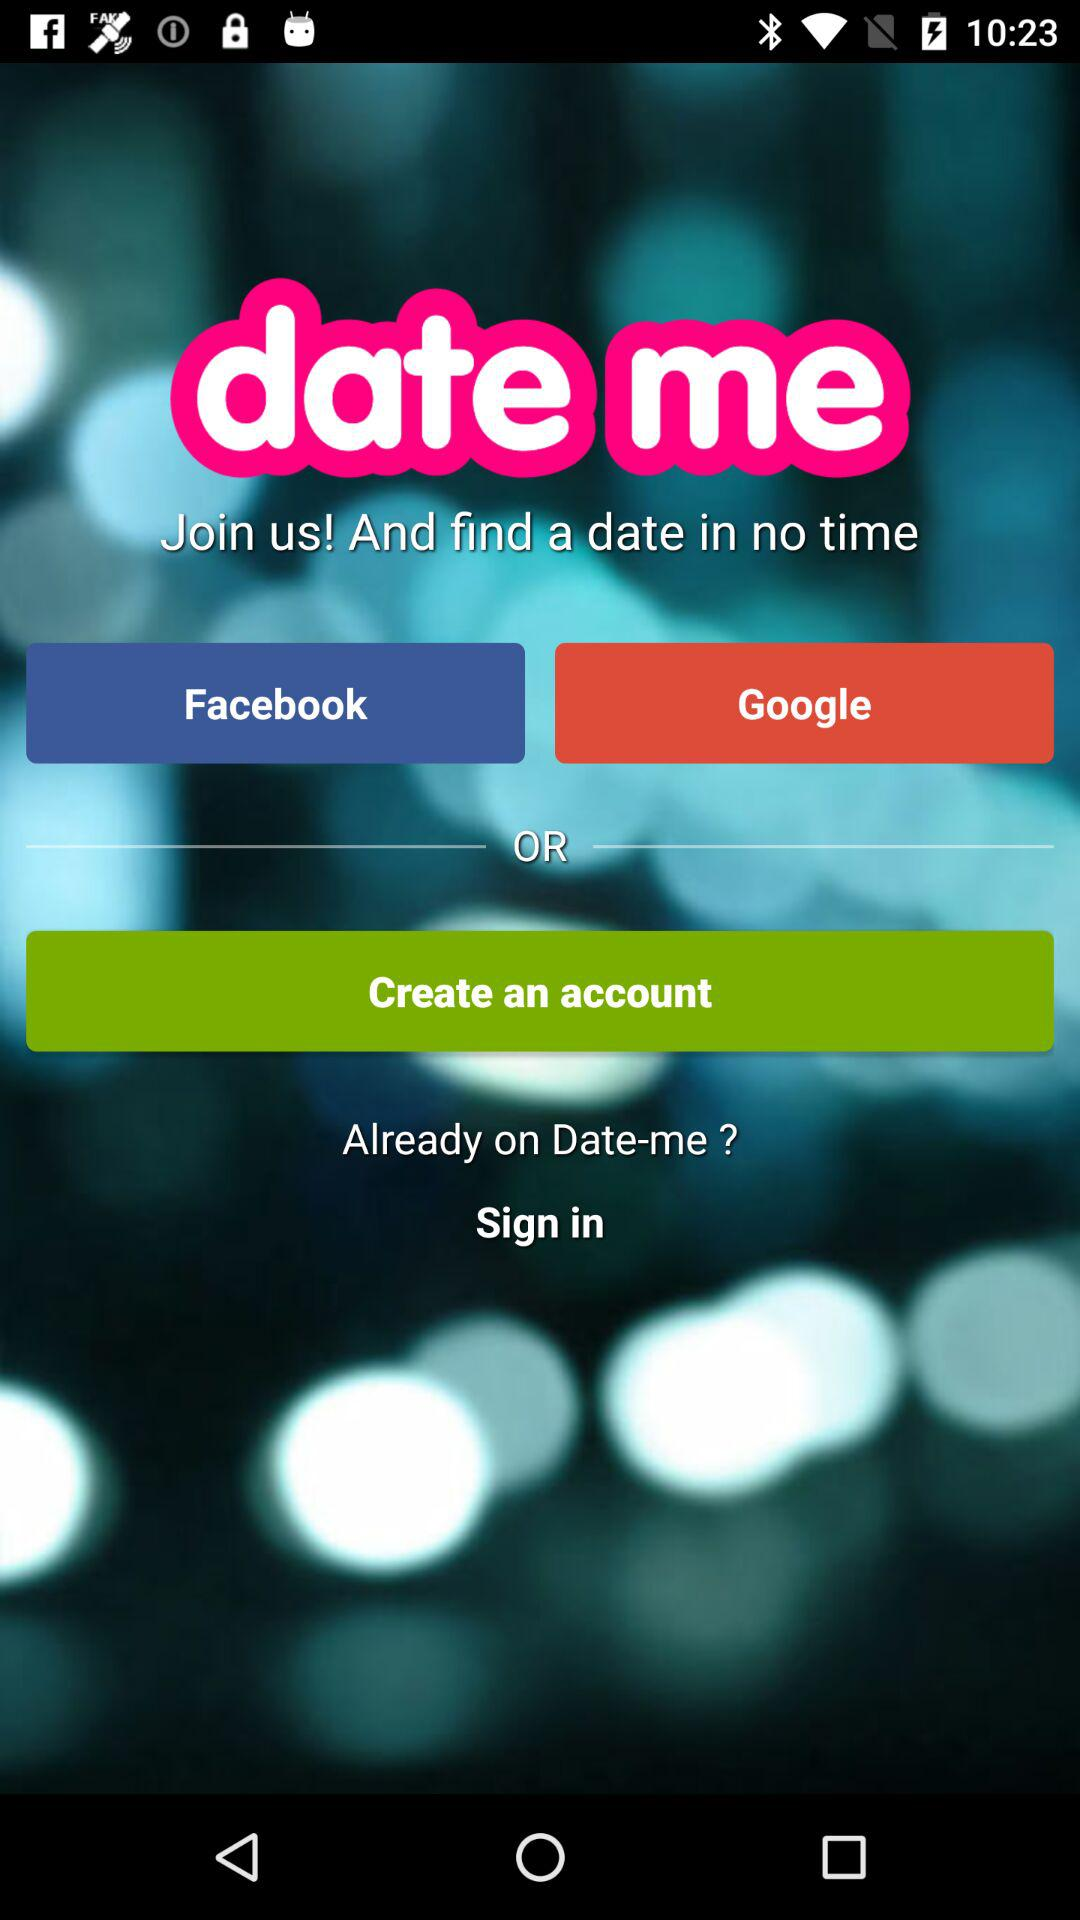What is the application name? The application name is "date me". 